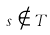<formula> <loc_0><loc_0><loc_500><loc_500>s \notin T</formula> 